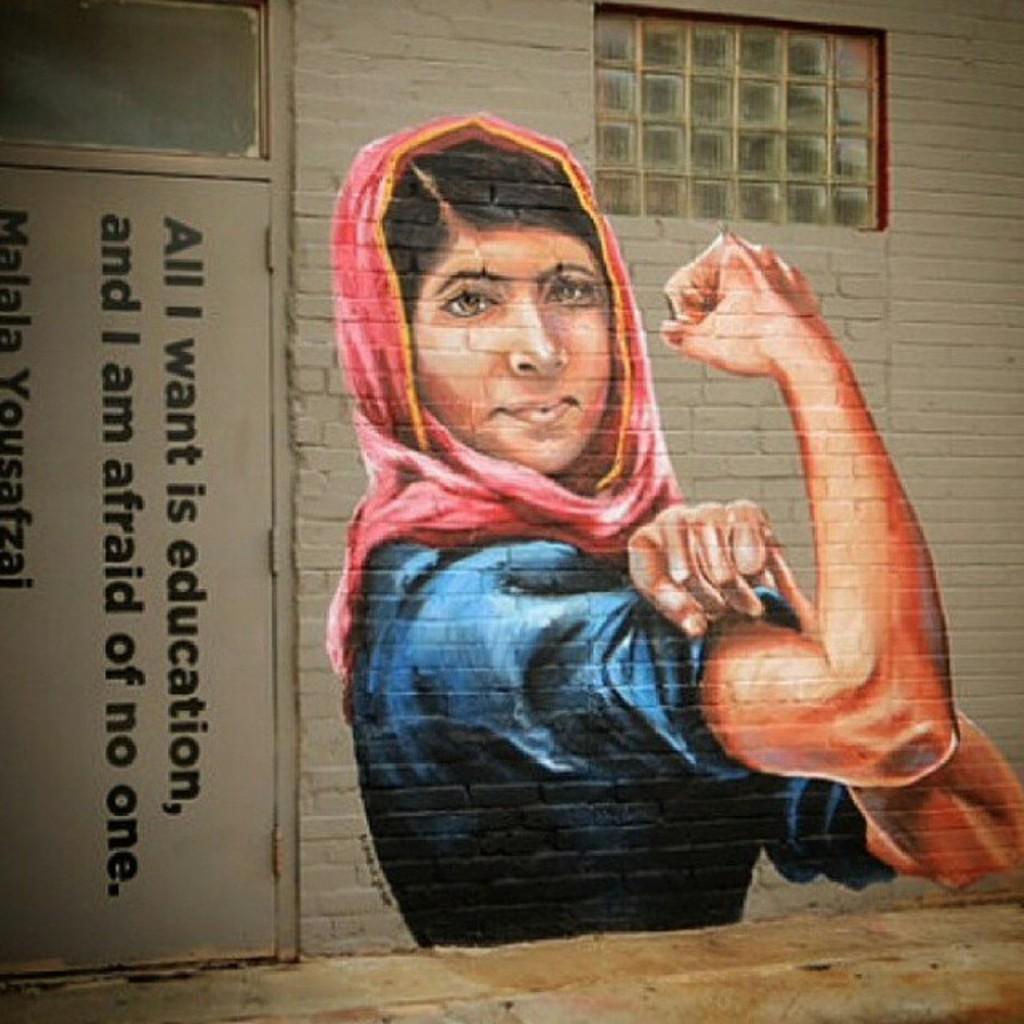Can you describe this image briefly? In the picture I can see the painting of a person on the wall of a house. This is looking like a metal door on the left side and I can see the text on the metal door. I can see the glass windows at the top of the image. 